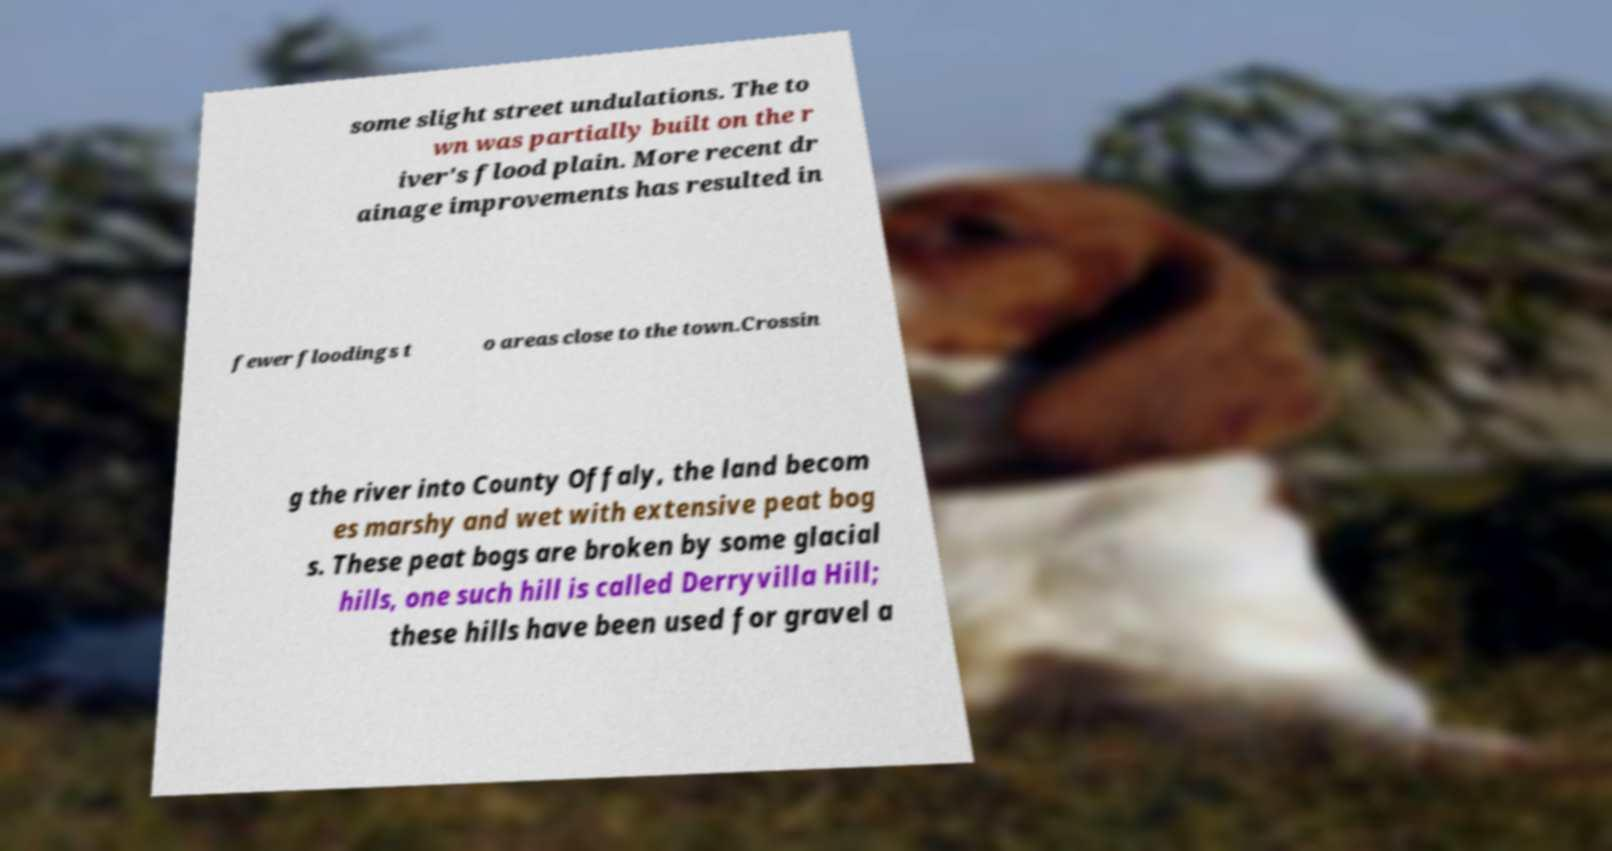Could you assist in decoding the text presented in this image and type it out clearly? some slight street undulations. The to wn was partially built on the r iver's flood plain. More recent dr ainage improvements has resulted in fewer floodings t o areas close to the town.Crossin g the river into County Offaly, the land becom es marshy and wet with extensive peat bog s. These peat bogs are broken by some glacial hills, one such hill is called Derryvilla Hill; these hills have been used for gravel a 